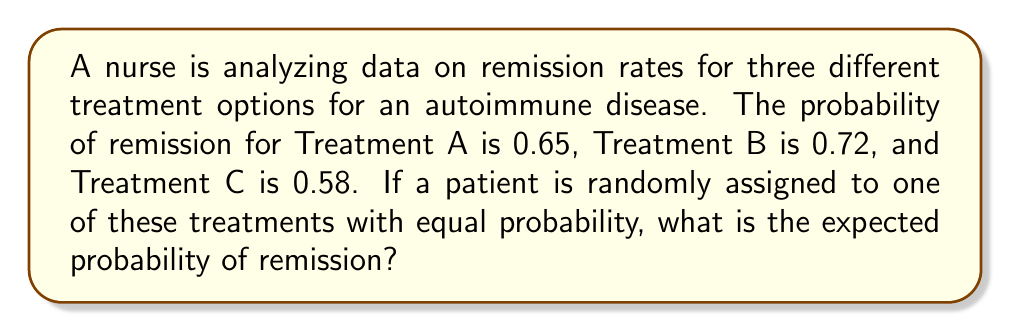Show me your answer to this math problem. To solve this problem, we need to use the concept of expected value. Since the treatments are assigned with equal probability, we can calculate the average of the remission probabilities.

Step 1: Identify the probabilities of remission for each treatment.
Treatment A: $p_A = 0.65$
Treatment B: $p_B = 0.72$
Treatment C: $p_C = 0.58$

Step 2: Calculate the probability of a patient being assigned to each treatment.
Since the assignment is random with equal probability, each treatment has a $\frac{1}{3}$ chance of being selected.

Step 3: Calculate the expected probability of remission using the formula for expected value:
$$E(X) = \sum_{i=1}^n p_i x_i$$
Where $p_i$ is the probability of each outcome and $x_i$ is the value of each outcome.

In this case:
$$E(X) = \frac{1}{3} \cdot 0.65 + \frac{1}{3} \cdot 0.72 + \frac{1}{3} \cdot 0.58$$

Step 4: Simplify the calculation:
$$E(X) = \frac{0.65 + 0.72 + 0.58}{3} = \frac{1.95}{3} = 0.65$$

Therefore, the expected probability of remission is 0.65 or 65%.
Answer: 0.65 